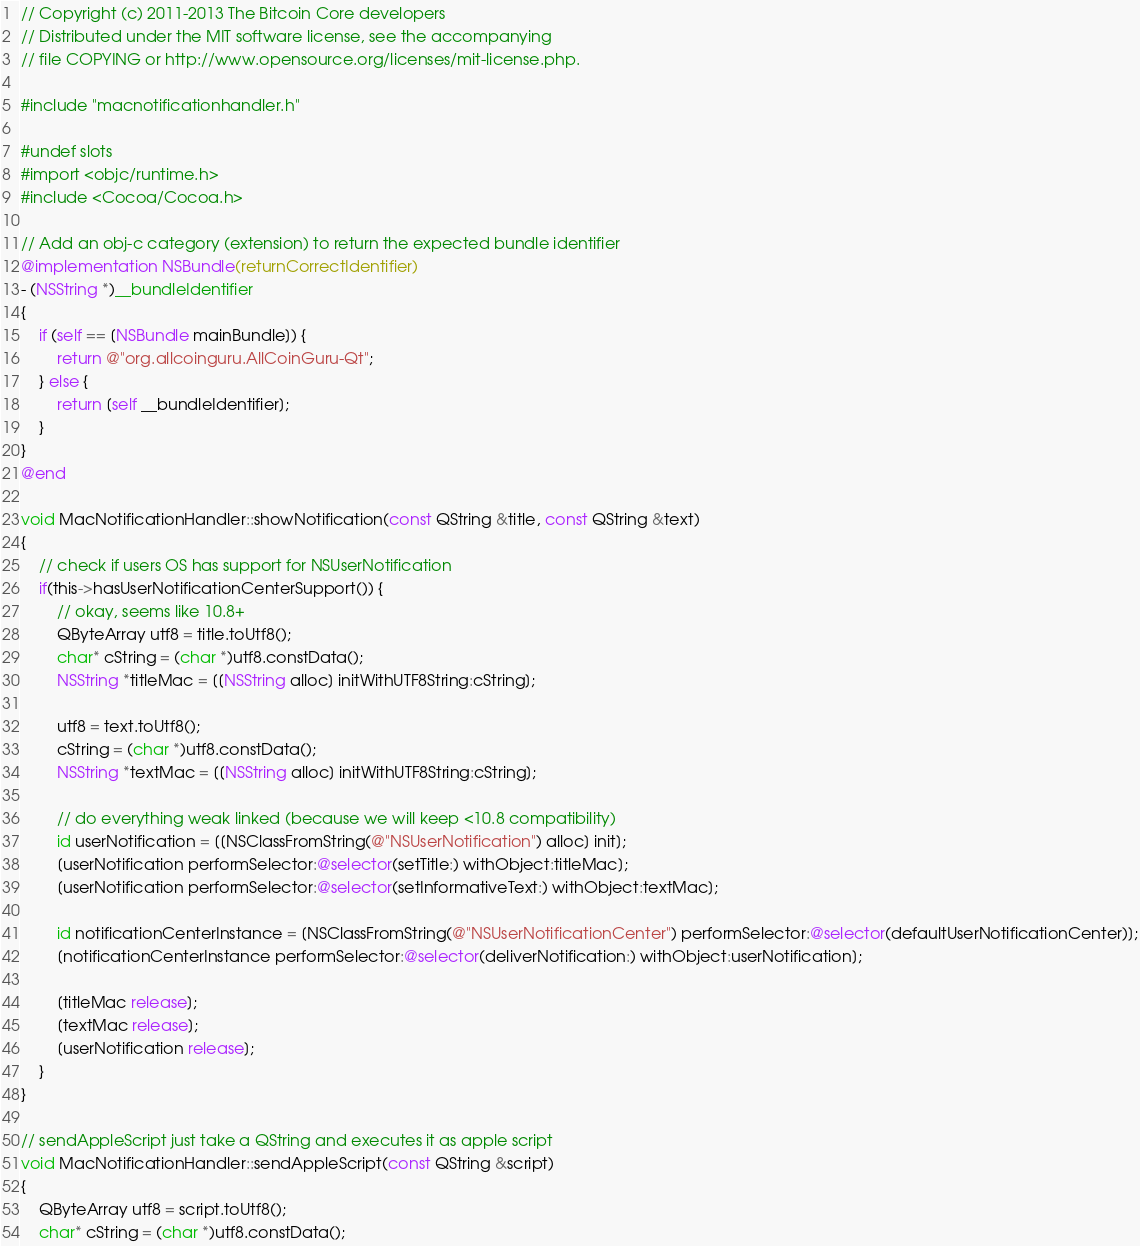Convert code to text. <code><loc_0><loc_0><loc_500><loc_500><_ObjectiveC_>// Copyright (c) 2011-2013 The Bitcoin Core developers
// Distributed under the MIT software license, see the accompanying
// file COPYING or http://www.opensource.org/licenses/mit-license.php.

#include "macnotificationhandler.h"

#undef slots
#import <objc/runtime.h>
#include <Cocoa/Cocoa.h>

// Add an obj-c category (extension) to return the expected bundle identifier
@implementation NSBundle(returnCorrectIdentifier)
- (NSString *)__bundleIdentifier
{
    if (self == [NSBundle mainBundle]) {
        return @"org.allcoinguru.AllCoinGuru-Qt";
    } else {
        return [self __bundleIdentifier];
    }
}
@end

void MacNotificationHandler::showNotification(const QString &title, const QString &text)
{
    // check if users OS has support for NSUserNotification
    if(this->hasUserNotificationCenterSupport()) {
        // okay, seems like 10.8+
        QByteArray utf8 = title.toUtf8();
        char* cString = (char *)utf8.constData();
        NSString *titleMac = [[NSString alloc] initWithUTF8String:cString];

        utf8 = text.toUtf8();
        cString = (char *)utf8.constData();
        NSString *textMac = [[NSString alloc] initWithUTF8String:cString];

        // do everything weak linked (because we will keep <10.8 compatibility)
        id userNotification = [[NSClassFromString(@"NSUserNotification") alloc] init];
        [userNotification performSelector:@selector(setTitle:) withObject:titleMac];
        [userNotification performSelector:@selector(setInformativeText:) withObject:textMac];

        id notificationCenterInstance = [NSClassFromString(@"NSUserNotificationCenter") performSelector:@selector(defaultUserNotificationCenter)];
        [notificationCenterInstance performSelector:@selector(deliverNotification:) withObject:userNotification];

        [titleMac release];
        [textMac release];
        [userNotification release];
    }
}

// sendAppleScript just take a QString and executes it as apple script
void MacNotificationHandler::sendAppleScript(const QString &script)
{
    QByteArray utf8 = script.toUtf8();
    char* cString = (char *)utf8.constData();</code> 